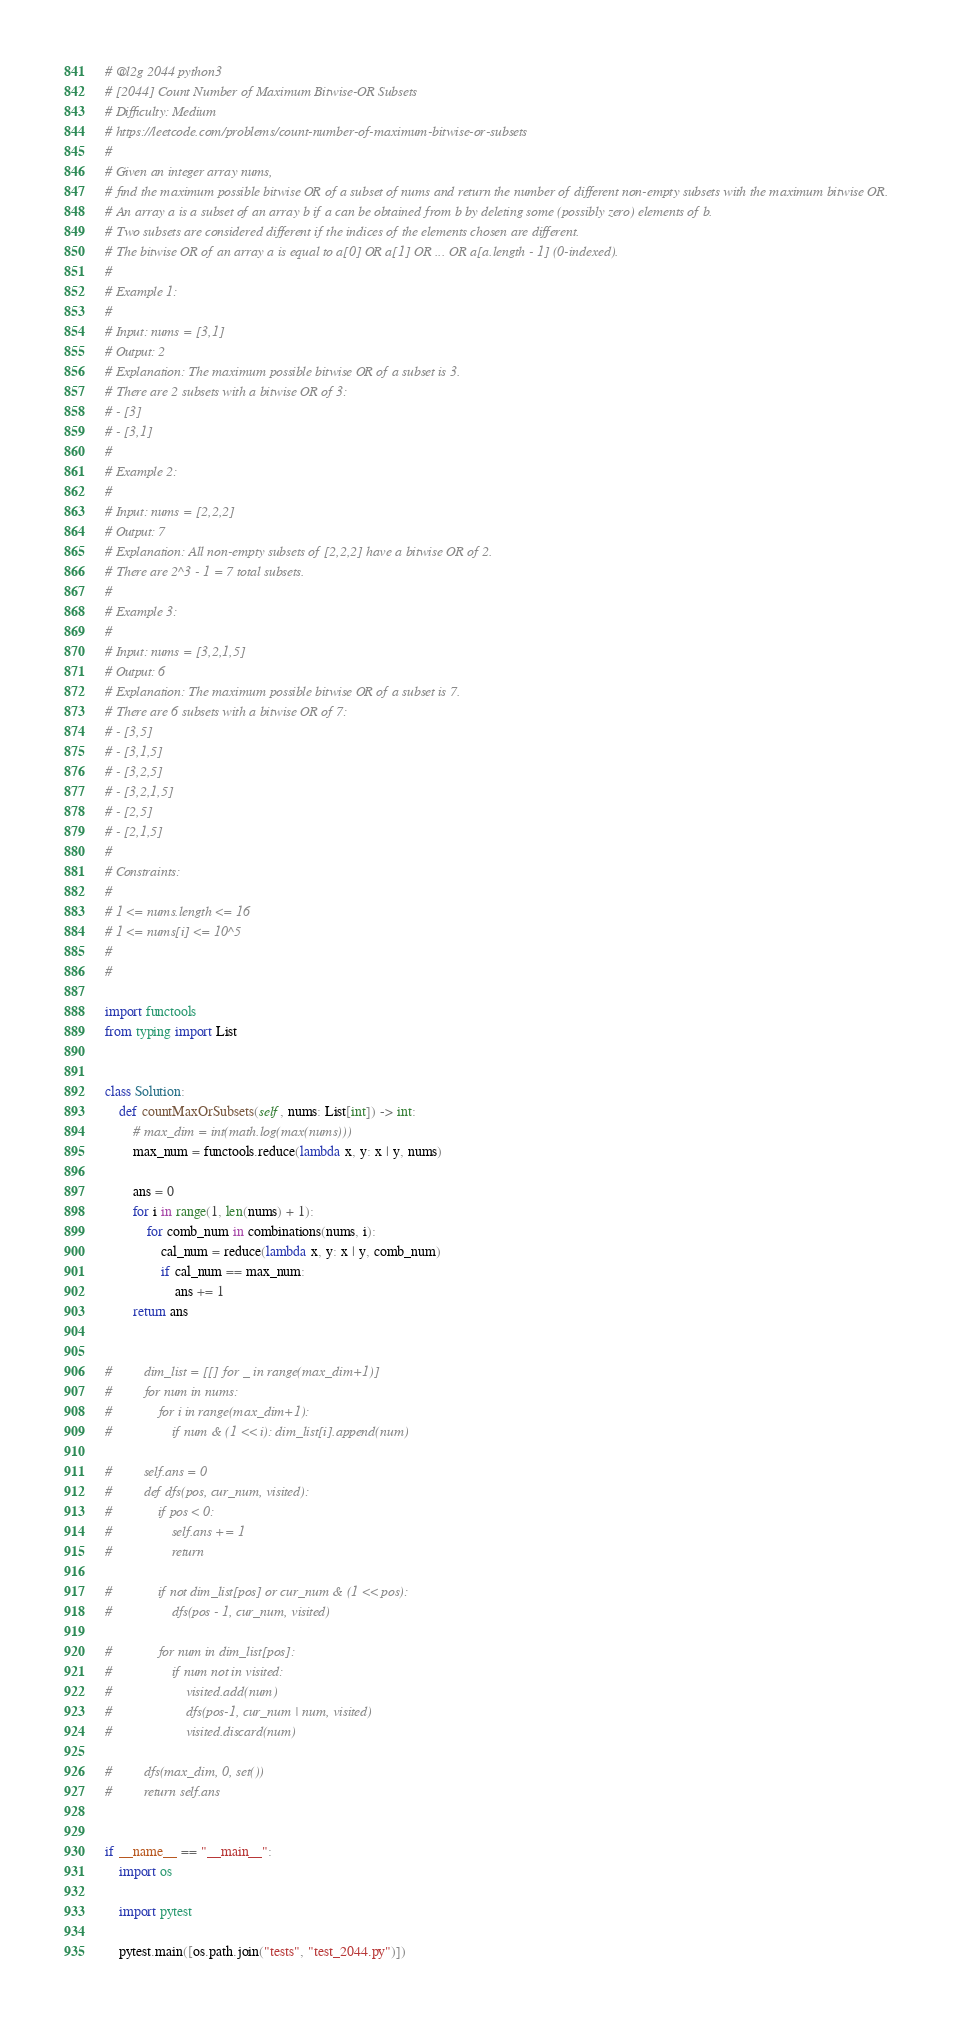<code> <loc_0><loc_0><loc_500><loc_500><_Python_># @l2g 2044 python3
# [2044] Count Number of Maximum Bitwise-OR Subsets
# Difficulty: Medium
# https://leetcode.com/problems/count-number-of-maximum-bitwise-or-subsets
#
# Given an integer array nums,
# find the maximum possible bitwise OR of a subset of nums and return the number of different non-empty subsets with the maximum bitwise OR.
# An array a is a subset of an array b if a can be obtained from b by deleting some (possibly zero) elements of b.
# Two subsets are considered different if the indices of the elements chosen are different.
# The bitwise OR of an array a is equal to a[0] OR a[1] OR ... OR a[a.length - 1] (0-indexed).
#
# Example 1:
#
# Input: nums = [3,1]
# Output: 2
# Explanation: The maximum possible bitwise OR of a subset is 3.
# There are 2 subsets with a bitwise OR of 3:
# - [3]
# - [3,1]
#
# Example 2:
#
# Input: nums = [2,2,2]
# Output: 7
# Explanation: All non-empty subsets of [2,2,2] have a bitwise OR of 2.
# There are 2^3 - 1 = 7 total subsets.
#
# Example 3:
#
# Input: nums = [3,2,1,5]
# Output: 6
# Explanation: The maximum possible bitwise OR of a subset is 7.
# There are 6 subsets with a bitwise OR of 7:
# - [3,5]
# - [3,1,5]
# - [3,2,5]
# - [3,2,1,5]
# - [2,5]
# - [2,1,5]
#
# Constraints:
#
# 1 <= nums.length <= 16
# 1 <= nums[i] <= 10^5
#
#

import functools
from typing import List


class Solution:
    def countMaxOrSubsets(self, nums: List[int]) -> int:
        # max_dim = int(math.log(max(nums)))
        max_num = functools.reduce(lambda x, y: x | y, nums)

        ans = 0
        for i in range(1, len(nums) + 1):
            for comb_num in combinations(nums, i):
                cal_num = reduce(lambda x, y: x | y, comb_num)
                if cal_num == max_num:
                    ans += 1
        return ans


#         dim_list = [[] for _ in range(max_dim+1)]
#         for num in nums:
#             for i in range(max_dim+1):
#                 if num & (1 << i): dim_list[i].append(num)

#         self.ans = 0
#         def dfs(pos, cur_num, visited):
#             if pos < 0:
#                 self.ans += 1
#                 return

#             if not dim_list[pos] or cur_num & (1 << pos):
#                 dfs(pos - 1, cur_num, visited)

#             for num in dim_list[pos]:
#                 if num not in visited:
#                     visited.add(num)
#                     dfs(pos-1, cur_num | num, visited)
#                     visited.discard(num)

#         dfs(max_dim, 0, set())
#         return self.ans


if __name__ == "__main__":
    import os

    import pytest

    pytest.main([os.path.join("tests", "test_2044.py")])
</code> 